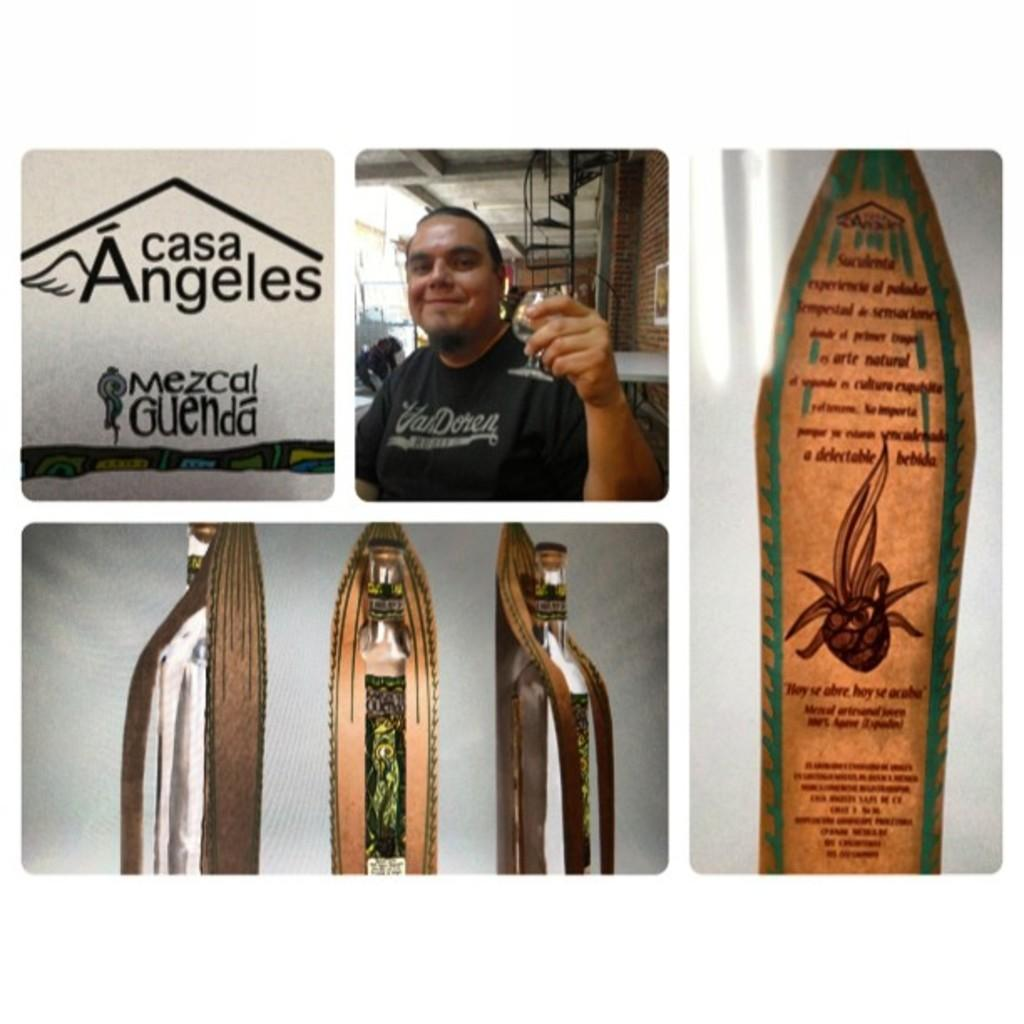What is the main feature of the image? The main feature of the image is that it contains multiple smaller images. Can you describe the second image? The second image contains a man. What objects are present in the bottom image? There are bottles in the bottom image. What is featured in the last image? The last image contains written script. What team is the man coaching in the second image? There is no indication of a team or any coaching activity in the second image; it simply shows a man. What addition problem is being solved in the last image? There is no addition problem or any mathematical content in the last image; it contains written script. 